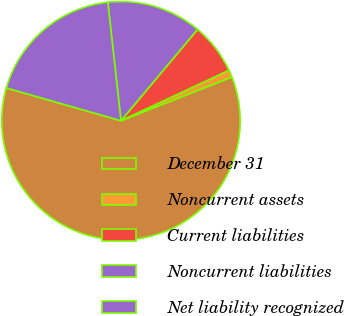<chart> <loc_0><loc_0><loc_500><loc_500><pie_chart><fcel>December 31<fcel>Noncurrent assets<fcel>Current liabilities<fcel>Noncurrent liabilities<fcel>Net liability recognized<nl><fcel>60.4%<fcel>0.99%<fcel>6.93%<fcel>12.87%<fcel>18.81%<nl></chart> 